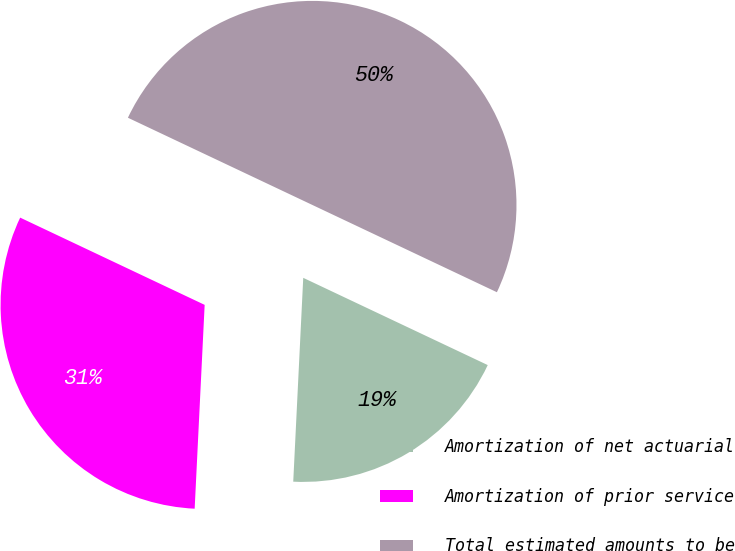Convert chart. <chart><loc_0><loc_0><loc_500><loc_500><pie_chart><fcel>Amortization of net actuarial<fcel>Amortization of prior service<fcel>Total estimated amounts to be<nl><fcel>18.75%<fcel>31.25%<fcel>50.0%<nl></chart> 